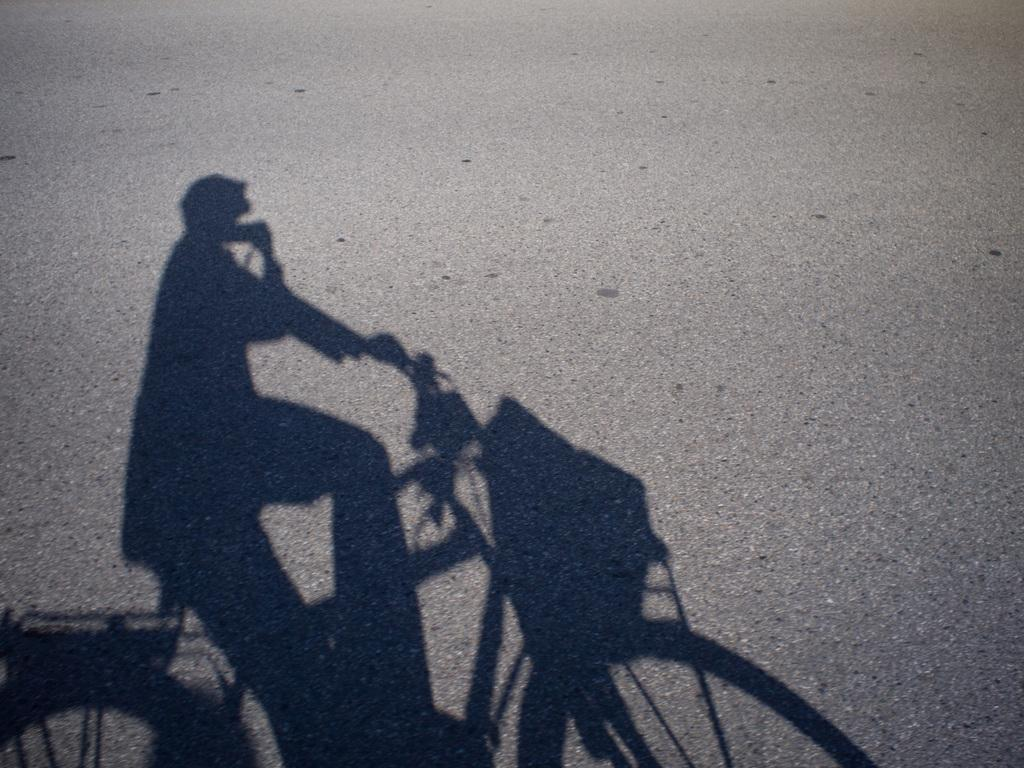What can be seen in the image that indicates the presence of a person? There is a shadow of a person in the image. What activity is the person engaged in? The person is riding a bicycle. What type of dress is the person wearing while riding the bicycle in the image? There is no information about the person's clothing in the image, so we cannot determine if they are wearing a dress or any other type of clothing. 